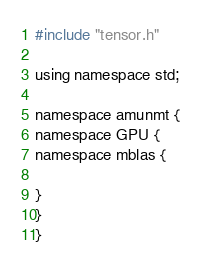<code> <loc_0><loc_0><loc_500><loc_500><_Cuda_>#include "tensor.h"

using namespace std;

namespace amunmt {
namespace GPU {
namespace mblas {

}
}
}
</code> 